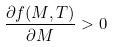<formula> <loc_0><loc_0><loc_500><loc_500>\frac { \partial f ( M , T ) } { \partial M } > 0</formula> 